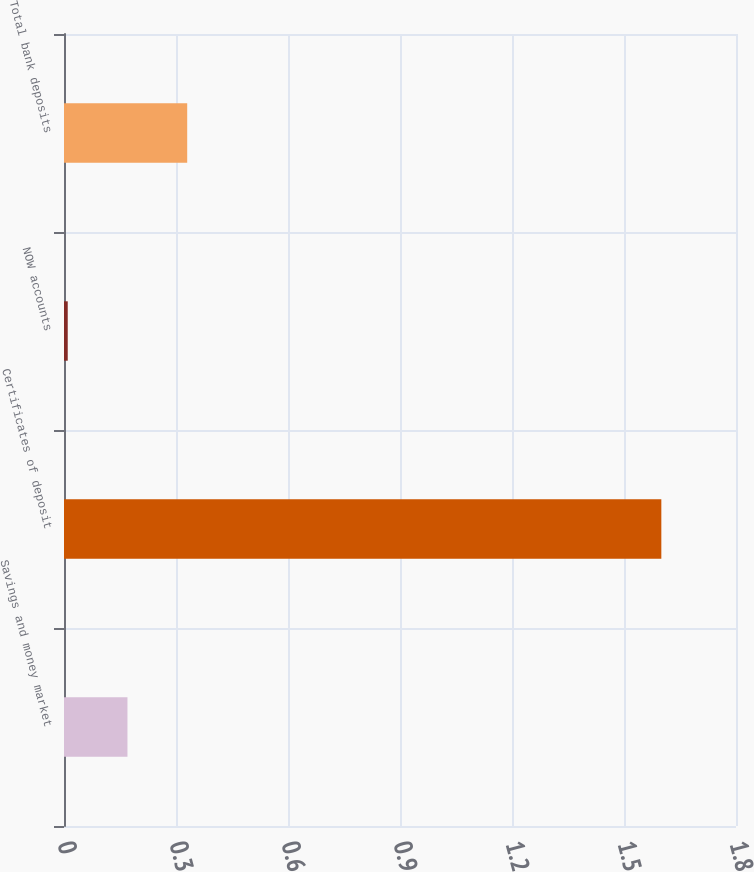<chart> <loc_0><loc_0><loc_500><loc_500><bar_chart><fcel>Savings and money market<fcel>Certificates of deposit<fcel>NOW accounts<fcel>Total bank deposits<nl><fcel>0.17<fcel>1.6<fcel>0.01<fcel>0.33<nl></chart> 